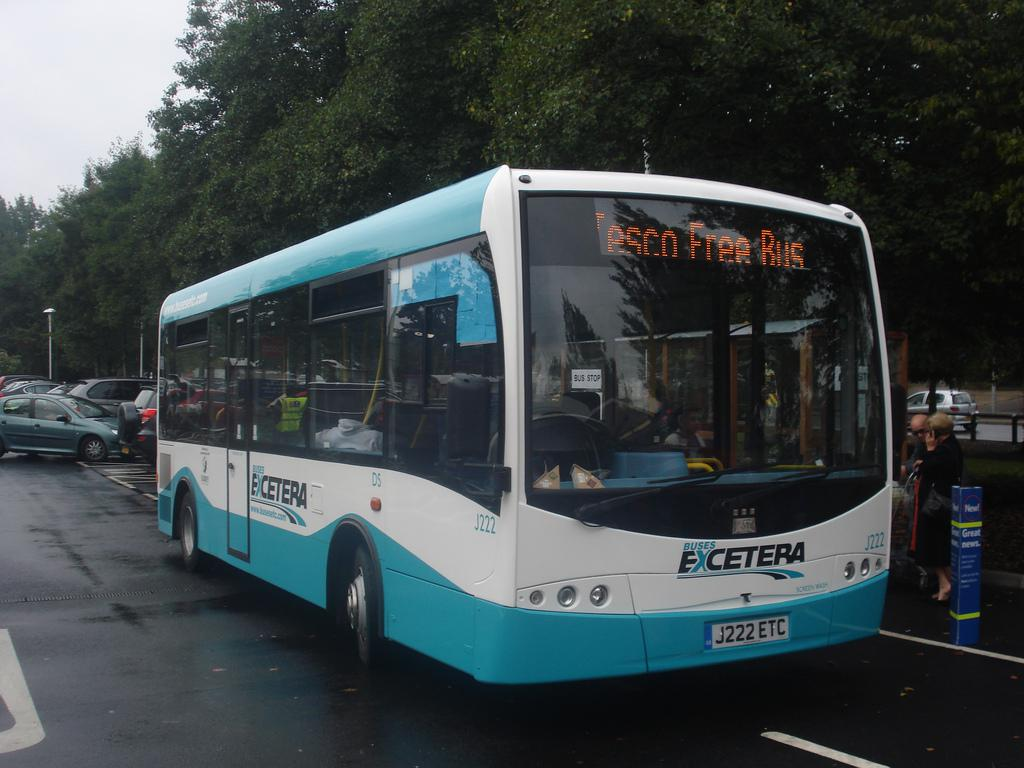Question: why would someone ride the bus?
Choices:
A. To travel.
B. To get to work.
C. Because the cost of parking is high downtown.
D. It is nice to not have to drive in bad weather.
Answer with the letter. Answer: A Question: where was this picture taken?
Choices:
A. On a bus.
B. On the street.
C. In the car.
D. At a bar.
Answer with the letter. Answer: B Question: what kind of day is it?
Choices:
A. Hot.
B. Overcast.
C. Rainy.
D. Cold.
Answer with the letter. Answer: B Question: how high does the bus come off the ground?
Choices:
A. Twenty feet.
B. Fifteen feet.
C. The bus sits low to the ground.
D. Ten feet.
Answer with the letter. Answer: C Question: how full are the trees in the background?
Choices:
A. Completely full.
B. Kind of full.
C. Not full at all.
D. They are fully covered in leaves.
Answer with the letter. Answer: D Question: how much does it cost to ride the bus?
Choices:
A. 2 dollars.
B. 50 cents.
C. Nothing.
D. 2 dollars and fifty cents.
Answer with the letter. Answer: C Question: who is standing to right of bus?
Choices:
A. Children.
B. Mother.
C. Older couple.
D. Teacher.
Answer with the letter. Answer: C Question: what's parked behind the bus?
Choices:
A. Motorcycles.
B. Volkeswagon bus.
C. Vespa scooters.
D. Cars.
Answer with the letter. Answer: D Question: what shape is the bus?
Choices:
A. A square.
B. A rectangle.
C. A tube.
D. A brick.
Answer with the letter. Answer: B Question: what is written on the front of the bus?
Choices:
A. Aflac.
B. State Farm.
C. Target.
D. Excetera.
Answer with the letter. Answer: D 